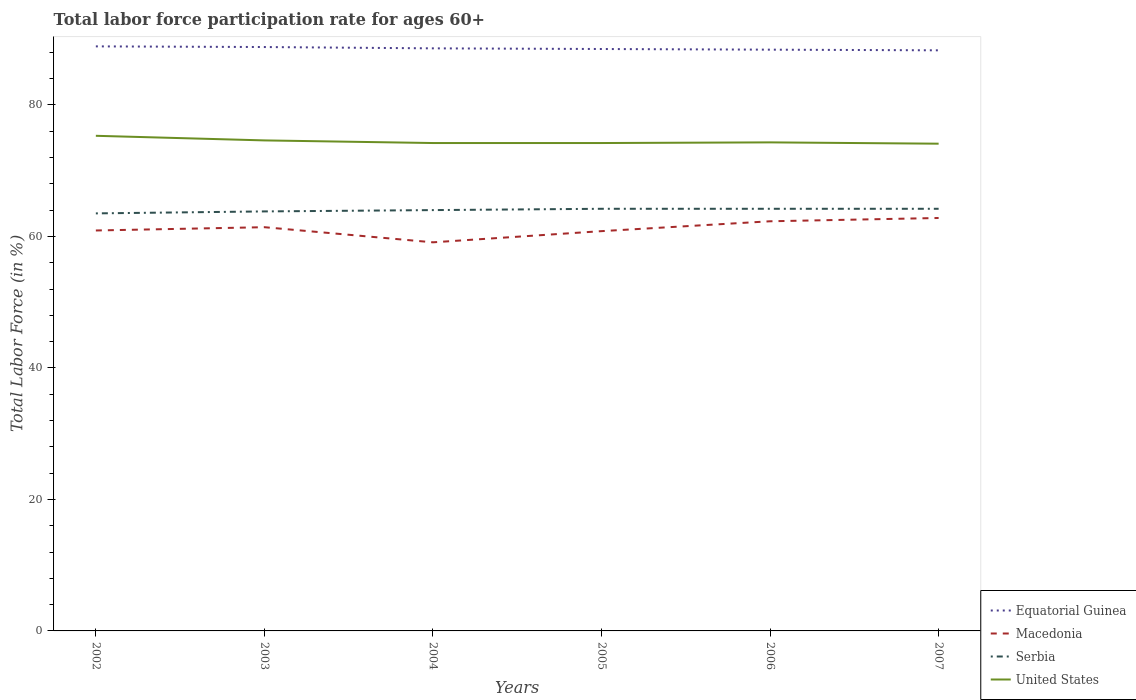How many different coloured lines are there?
Provide a short and direct response. 4. Does the line corresponding to Equatorial Guinea intersect with the line corresponding to Serbia?
Make the answer very short. No. Across all years, what is the maximum labor force participation rate in Serbia?
Your answer should be very brief. 63.5. In which year was the labor force participation rate in United States maximum?
Your answer should be compact. 2007. What is the total labor force participation rate in United States in the graph?
Offer a very short reply. -0.1. What is the difference between the highest and the second highest labor force participation rate in Macedonia?
Give a very brief answer. 3.7. How many lines are there?
Keep it short and to the point. 4. What is the difference between two consecutive major ticks on the Y-axis?
Give a very brief answer. 20. Does the graph contain any zero values?
Keep it short and to the point. No. Where does the legend appear in the graph?
Provide a succinct answer. Bottom right. How many legend labels are there?
Make the answer very short. 4. What is the title of the graph?
Provide a succinct answer. Total labor force participation rate for ages 60+. What is the Total Labor Force (in %) in Equatorial Guinea in 2002?
Your response must be concise. 88.9. What is the Total Labor Force (in %) of Macedonia in 2002?
Provide a succinct answer. 60.9. What is the Total Labor Force (in %) of Serbia in 2002?
Make the answer very short. 63.5. What is the Total Labor Force (in %) of United States in 2002?
Ensure brevity in your answer.  75.3. What is the Total Labor Force (in %) of Equatorial Guinea in 2003?
Make the answer very short. 88.8. What is the Total Labor Force (in %) in Macedonia in 2003?
Provide a short and direct response. 61.4. What is the Total Labor Force (in %) in Serbia in 2003?
Make the answer very short. 63.8. What is the Total Labor Force (in %) in United States in 2003?
Make the answer very short. 74.6. What is the Total Labor Force (in %) in Equatorial Guinea in 2004?
Ensure brevity in your answer.  88.6. What is the Total Labor Force (in %) of Macedonia in 2004?
Provide a short and direct response. 59.1. What is the Total Labor Force (in %) in United States in 2004?
Provide a short and direct response. 74.2. What is the Total Labor Force (in %) of Equatorial Guinea in 2005?
Make the answer very short. 88.5. What is the Total Labor Force (in %) of Macedonia in 2005?
Your answer should be very brief. 60.8. What is the Total Labor Force (in %) of Serbia in 2005?
Your response must be concise. 64.2. What is the Total Labor Force (in %) of United States in 2005?
Your response must be concise. 74.2. What is the Total Labor Force (in %) in Equatorial Guinea in 2006?
Offer a very short reply. 88.4. What is the Total Labor Force (in %) in Macedonia in 2006?
Your answer should be compact. 62.3. What is the Total Labor Force (in %) of Serbia in 2006?
Your answer should be very brief. 64.2. What is the Total Labor Force (in %) of United States in 2006?
Offer a very short reply. 74.3. What is the Total Labor Force (in %) of Equatorial Guinea in 2007?
Your response must be concise. 88.3. What is the Total Labor Force (in %) of Macedonia in 2007?
Give a very brief answer. 62.8. What is the Total Labor Force (in %) of Serbia in 2007?
Keep it short and to the point. 64.2. What is the Total Labor Force (in %) in United States in 2007?
Offer a very short reply. 74.1. Across all years, what is the maximum Total Labor Force (in %) of Equatorial Guinea?
Your answer should be compact. 88.9. Across all years, what is the maximum Total Labor Force (in %) in Macedonia?
Your response must be concise. 62.8. Across all years, what is the maximum Total Labor Force (in %) in Serbia?
Keep it short and to the point. 64.2. Across all years, what is the maximum Total Labor Force (in %) in United States?
Make the answer very short. 75.3. Across all years, what is the minimum Total Labor Force (in %) of Equatorial Guinea?
Make the answer very short. 88.3. Across all years, what is the minimum Total Labor Force (in %) of Macedonia?
Provide a succinct answer. 59.1. Across all years, what is the minimum Total Labor Force (in %) of Serbia?
Provide a short and direct response. 63.5. Across all years, what is the minimum Total Labor Force (in %) of United States?
Give a very brief answer. 74.1. What is the total Total Labor Force (in %) in Equatorial Guinea in the graph?
Your answer should be compact. 531.5. What is the total Total Labor Force (in %) of Macedonia in the graph?
Ensure brevity in your answer.  367.3. What is the total Total Labor Force (in %) of Serbia in the graph?
Give a very brief answer. 383.9. What is the total Total Labor Force (in %) in United States in the graph?
Your answer should be compact. 446.7. What is the difference between the Total Labor Force (in %) in Equatorial Guinea in 2002 and that in 2003?
Your answer should be very brief. 0.1. What is the difference between the Total Labor Force (in %) of Macedonia in 2002 and that in 2003?
Keep it short and to the point. -0.5. What is the difference between the Total Labor Force (in %) of Serbia in 2002 and that in 2003?
Make the answer very short. -0.3. What is the difference between the Total Labor Force (in %) of United States in 2002 and that in 2004?
Your response must be concise. 1.1. What is the difference between the Total Labor Force (in %) in Serbia in 2002 and that in 2005?
Your response must be concise. -0.7. What is the difference between the Total Labor Force (in %) in Equatorial Guinea in 2002 and that in 2006?
Your answer should be very brief. 0.5. What is the difference between the Total Labor Force (in %) of United States in 2002 and that in 2006?
Provide a short and direct response. 1. What is the difference between the Total Labor Force (in %) in Equatorial Guinea in 2002 and that in 2007?
Offer a terse response. 0.6. What is the difference between the Total Labor Force (in %) of Serbia in 2002 and that in 2007?
Your answer should be very brief. -0.7. What is the difference between the Total Labor Force (in %) of Equatorial Guinea in 2003 and that in 2004?
Provide a short and direct response. 0.2. What is the difference between the Total Labor Force (in %) of Macedonia in 2003 and that in 2004?
Your answer should be compact. 2.3. What is the difference between the Total Labor Force (in %) in United States in 2003 and that in 2004?
Your response must be concise. 0.4. What is the difference between the Total Labor Force (in %) in Macedonia in 2003 and that in 2005?
Make the answer very short. 0.6. What is the difference between the Total Labor Force (in %) of United States in 2003 and that in 2005?
Your answer should be compact. 0.4. What is the difference between the Total Labor Force (in %) of Equatorial Guinea in 2003 and that in 2006?
Make the answer very short. 0.4. What is the difference between the Total Labor Force (in %) of Macedonia in 2003 and that in 2006?
Provide a succinct answer. -0.9. What is the difference between the Total Labor Force (in %) in Macedonia in 2004 and that in 2005?
Provide a succinct answer. -1.7. What is the difference between the Total Labor Force (in %) in Macedonia in 2004 and that in 2007?
Ensure brevity in your answer.  -3.7. What is the difference between the Total Labor Force (in %) in United States in 2004 and that in 2007?
Your answer should be compact. 0.1. What is the difference between the Total Labor Force (in %) of United States in 2005 and that in 2006?
Provide a short and direct response. -0.1. What is the difference between the Total Labor Force (in %) of Serbia in 2005 and that in 2007?
Keep it short and to the point. 0. What is the difference between the Total Labor Force (in %) of United States in 2005 and that in 2007?
Make the answer very short. 0.1. What is the difference between the Total Labor Force (in %) of Serbia in 2006 and that in 2007?
Offer a terse response. 0. What is the difference between the Total Labor Force (in %) in Equatorial Guinea in 2002 and the Total Labor Force (in %) in Macedonia in 2003?
Your answer should be very brief. 27.5. What is the difference between the Total Labor Force (in %) in Equatorial Guinea in 2002 and the Total Labor Force (in %) in Serbia in 2003?
Your answer should be compact. 25.1. What is the difference between the Total Labor Force (in %) in Macedonia in 2002 and the Total Labor Force (in %) in United States in 2003?
Provide a succinct answer. -13.7. What is the difference between the Total Labor Force (in %) of Serbia in 2002 and the Total Labor Force (in %) of United States in 2003?
Keep it short and to the point. -11.1. What is the difference between the Total Labor Force (in %) in Equatorial Guinea in 2002 and the Total Labor Force (in %) in Macedonia in 2004?
Provide a short and direct response. 29.8. What is the difference between the Total Labor Force (in %) in Equatorial Guinea in 2002 and the Total Labor Force (in %) in Serbia in 2004?
Your answer should be very brief. 24.9. What is the difference between the Total Labor Force (in %) in Macedonia in 2002 and the Total Labor Force (in %) in Serbia in 2004?
Provide a succinct answer. -3.1. What is the difference between the Total Labor Force (in %) of Macedonia in 2002 and the Total Labor Force (in %) of United States in 2004?
Your response must be concise. -13.3. What is the difference between the Total Labor Force (in %) of Equatorial Guinea in 2002 and the Total Labor Force (in %) of Macedonia in 2005?
Provide a short and direct response. 28.1. What is the difference between the Total Labor Force (in %) in Equatorial Guinea in 2002 and the Total Labor Force (in %) in Serbia in 2005?
Your answer should be very brief. 24.7. What is the difference between the Total Labor Force (in %) in Equatorial Guinea in 2002 and the Total Labor Force (in %) in United States in 2005?
Provide a short and direct response. 14.7. What is the difference between the Total Labor Force (in %) of Macedonia in 2002 and the Total Labor Force (in %) of Serbia in 2005?
Ensure brevity in your answer.  -3.3. What is the difference between the Total Labor Force (in %) in Serbia in 2002 and the Total Labor Force (in %) in United States in 2005?
Offer a very short reply. -10.7. What is the difference between the Total Labor Force (in %) of Equatorial Guinea in 2002 and the Total Labor Force (in %) of Macedonia in 2006?
Offer a very short reply. 26.6. What is the difference between the Total Labor Force (in %) of Equatorial Guinea in 2002 and the Total Labor Force (in %) of Serbia in 2006?
Offer a terse response. 24.7. What is the difference between the Total Labor Force (in %) in Equatorial Guinea in 2002 and the Total Labor Force (in %) in United States in 2006?
Keep it short and to the point. 14.6. What is the difference between the Total Labor Force (in %) of Macedonia in 2002 and the Total Labor Force (in %) of Serbia in 2006?
Offer a terse response. -3.3. What is the difference between the Total Labor Force (in %) in Macedonia in 2002 and the Total Labor Force (in %) in United States in 2006?
Give a very brief answer. -13.4. What is the difference between the Total Labor Force (in %) of Serbia in 2002 and the Total Labor Force (in %) of United States in 2006?
Your answer should be compact. -10.8. What is the difference between the Total Labor Force (in %) of Equatorial Guinea in 2002 and the Total Labor Force (in %) of Macedonia in 2007?
Make the answer very short. 26.1. What is the difference between the Total Labor Force (in %) in Equatorial Guinea in 2002 and the Total Labor Force (in %) in Serbia in 2007?
Provide a short and direct response. 24.7. What is the difference between the Total Labor Force (in %) of Macedonia in 2002 and the Total Labor Force (in %) of Serbia in 2007?
Your response must be concise. -3.3. What is the difference between the Total Labor Force (in %) of Equatorial Guinea in 2003 and the Total Labor Force (in %) of Macedonia in 2004?
Keep it short and to the point. 29.7. What is the difference between the Total Labor Force (in %) of Equatorial Guinea in 2003 and the Total Labor Force (in %) of Serbia in 2004?
Offer a very short reply. 24.8. What is the difference between the Total Labor Force (in %) of Equatorial Guinea in 2003 and the Total Labor Force (in %) of United States in 2004?
Keep it short and to the point. 14.6. What is the difference between the Total Labor Force (in %) in Macedonia in 2003 and the Total Labor Force (in %) in Serbia in 2004?
Your answer should be compact. -2.6. What is the difference between the Total Labor Force (in %) in Equatorial Guinea in 2003 and the Total Labor Force (in %) in Macedonia in 2005?
Make the answer very short. 28. What is the difference between the Total Labor Force (in %) of Equatorial Guinea in 2003 and the Total Labor Force (in %) of Serbia in 2005?
Keep it short and to the point. 24.6. What is the difference between the Total Labor Force (in %) of Macedonia in 2003 and the Total Labor Force (in %) of Serbia in 2005?
Provide a succinct answer. -2.8. What is the difference between the Total Labor Force (in %) in Serbia in 2003 and the Total Labor Force (in %) in United States in 2005?
Make the answer very short. -10.4. What is the difference between the Total Labor Force (in %) in Equatorial Guinea in 2003 and the Total Labor Force (in %) in Macedonia in 2006?
Keep it short and to the point. 26.5. What is the difference between the Total Labor Force (in %) in Equatorial Guinea in 2003 and the Total Labor Force (in %) in Serbia in 2006?
Offer a terse response. 24.6. What is the difference between the Total Labor Force (in %) in Equatorial Guinea in 2003 and the Total Labor Force (in %) in Serbia in 2007?
Give a very brief answer. 24.6. What is the difference between the Total Labor Force (in %) of Serbia in 2003 and the Total Labor Force (in %) of United States in 2007?
Ensure brevity in your answer.  -10.3. What is the difference between the Total Labor Force (in %) of Equatorial Guinea in 2004 and the Total Labor Force (in %) of Macedonia in 2005?
Ensure brevity in your answer.  27.8. What is the difference between the Total Labor Force (in %) in Equatorial Guinea in 2004 and the Total Labor Force (in %) in Serbia in 2005?
Offer a terse response. 24.4. What is the difference between the Total Labor Force (in %) of Macedonia in 2004 and the Total Labor Force (in %) of United States in 2005?
Make the answer very short. -15.1. What is the difference between the Total Labor Force (in %) in Equatorial Guinea in 2004 and the Total Labor Force (in %) in Macedonia in 2006?
Your response must be concise. 26.3. What is the difference between the Total Labor Force (in %) of Equatorial Guinea in 2004 and the Total Labor Force (in %) of Serbia in 2006?
Offer a terse response. 24.4. What is the difference between the Total Labor Force (in %) in Macedonia in 2004 and the Total Labor Force (in %) in Serbia in 2006?
Provide a short and direct response. -5.1. What is the difference between the Total Labor Force (in %) in Macedonia in 2004 and the Total Labor Force (in %) in United States in 2006?
Offer a terse response. -15.2. What is the difference between the Total Labor Force (in %) of Equatorial Guinea in 2004 and the Total Labor Force (in %) of Macedonia in 2007?
Your response must be concise. 25.8. What is the difference between the Total Labor Force (in %) of Equatorial Guinea in 2004 and the Total Labor Force (in %) of Serbia in 2007?
Your response must be concise. 24.4. What is the difference between the Total Labor Force (in %) in Macedonia in 2004 and the Total Labor Force (in %) in Serbia in 2007?
Your response must be concise. -5.1. What is the difference between the Total Labor Force (in %) of Macedonia in 2004 and the Total Labor Force (in %) of United States in 2007?
Ensure brevity in your answer.  -15. What is the difference between the Total Labor Force (in %) in Serbia in 2004 and the Total Labor Force (in %) in United States in 2007?
Make the answer very short. -10.1. What is the difference between the Total Labor Force (in %) in Equatorial Guinea in 2005 and the Total Labor Force (in %) in Macedonia in 2006?
Your response must be concise. 26.2. What is the difference between the Total Labor Force (in %) of Equatorial Guinea in 2005 and the Total Labor Force (in %) of Serbia in 2006?
Offer a very short reply. 24.3. What is the difference between the Total Labor Force (in %) of Equatorial Guinea in 2005 and the Total Labor Force (in %) of United States in 2006?
Make the answer very short. 14.2. What is the difference between the Total Labor Force (in %) of Serbia in 2005 and the Total Labor Force (in %) of United States in 2006?
Provide a succinct answer. -10.1. What is the difference between the Total Labor Force (in %) in Equatorial Guinea in 2005 and the Total Labor Force (in %) in Macedonia in 2007?
Keep it short and to the point. 25.7. What is the difference between the Total Labor Force (in %) of Equatorial Guinea in 2005 and the Total Labor Force (in %) of Serbia in 2007?
Your answer should be compact. 24.3. What is the difference between the Total Labor Force (in %) in Macedonia in 2005 and the Total Labor Force (in %) in United States in 2007?
Provide a succinct answer. -13.3. What is the difference between the Total Labor Force (in %) of Equatorial Guinea in 2006 and the Total Labor Force (in %) of Macedonia in 2007?
Ensure brevity in your answer.  25.6. What is the difference between the Total Labor Force (in %) in Equatorial Guinea in 2006 and the Total Labor Force (in %) in Serbia in 2007?
Give a very brief answer. 24.2. What is the difference between the Total Labor Force (in %) in Equatorial Guinea in 2006 and the Total Labor Force (in %) in United States in 2007?
Your answer should be very brief. 14.3. What is the difference between the Total Labor Force (in %) of Macedonia in 2006 and the Total Labor Force (in %) of Serbia in 2007?
Keep it short and to the point. -1.9. What is the difference between the Total Labor Force (in %) in Serbia in 2006 and the Total Labor Force (in %) in United States in 2007?
Keep it short and to the point. -9.9. What is the average Total Labor Force (in %) in Equatorial Guinea per year?
Keep it short and to the point. 88.58. What is the average Total Labor Force (in %) of Macedonia per year?
Provide a succinct answer. 61.22. What is the average Total Labor Force (in %) in Serbia per year?
Your response must be concise. 63.98. What is the average Total Labor Force (in %) in United States per year?
Your response must be concise. 74.45. In the year 2002, what is the difference between the Total Labor Force (in %) of Equatorial Guinea and Total Labor Force (in %) of Macedonia?
Make the answer very short. 28. In the year 2002, what is the difference between the Total Labor Force (in %) in Equatorial Guinea and Total Labor Force (in %) in Serbia?
Offer a very short reply. 25.4. In the year 2002, what is the difference between the Total Labor Force (in %) of Equatorial Guinea and Total Labor Force (in %) of United States?
Your answer should be compact. 13.6. In the year 2002, what is the difference between the Total Labor Force (in %) of Macedonia and Total Labor Force (in %) of United States?
Provide a short and direct response. -14.4. In the year 2002, what is the difference between the Total Labor Force (in %) in Serbia and Total Labor Force (in %) in United States?
Provide a short and direct response. -11.8. In the year 2003, what is the difference between the Total Labor Force (in %) of Equatorial Guinea and Total Labor Force (in %) of Macedonia?
Your answer should be compact. 27.4. In the year 2003, what is the difference between the Total Labor Force (in %) of Macedonia and Total Labor Force (in %) of United States?
Keep it short and to the point. -13.2. In the year 2003, what is the difference between the Total Labor Force (in %) in Serbia and Total Labor Force (in %) in United States?
Your answer should be very brief. -10.8. In the year 2004, what is the difference between the Total Labor Force (in %) in Equatorial Guinea and Total Labor Force (in %) in Macedonia?
Make the answer very short. 29.5. In the year 2004, what is the difference between the Total Labor Force (in %) in Equatorial Guinea and Total Labor Force (in %) in Serbia?
Offer a very short reply. 24.6. In the year 2004, what is the difference between the Total Labor Force (in %) of Equatorial Guinea and Total Labor Force (in %) of United States?
Your answer should be compact. 14.4. In the year 2004, what is the difference between the Total Labor Force (in %) in Macedonia and Total Labor Force (in %) in United States?
Keep it short and to the point. -15.1. In the year 2004, what is the difference between the Total Labor Force (in %) of Serbia and Total Labor Force (in %) of United States?
Keep it short and to the point. -10.2. In the year 2005, what is the difference between the Total Labor Force (in %) of Equatorial Guinea and Total Labor Force (in %) of Macedonia?
Give a very brief answer. 27.7. In the year 2005, what is the difference between the Total Labor Force (in %) of Equatorial Guinea and Total Labor Force (in %) of Serbia?
Provide a short and direct response. 24.3. In the year 2005, what is the difference between the Total Labor Force (in %) of Equatorial Guinea and Total Labor Force (in %) of United States?
Provide a short and direct response. 14.3. In the year 2005, what is the difference between the Total Labor Force (in %) in Serbia and Total Labor Force (in %) in United States?
Your answer should be very brief. -10. In the year 2006, what is the difference between the Total Labor Force (in %) in Equatorial Guinea and Total Labor Force (in %) in Macedonia?
Offer a terse response. 26.1. In the year 2006, what is the difference between the Total Labor Force (in %) of Equatorial Guinea and Total Labor Force (in %) of Serbia?
Your answer should be compact. 24.2. In the year 2006, what is the difference between the Total Labor Force (in %) in Macedonia and Total Labor Force (in %) in Serbia?
Give a very brief answer. -1.9. In the year 2006, what is the difference between the Total Labor Force (in %) of Macedonia and Total Labor Force (in %) of United States?
Your response must be concise. -12. In the year 2006, what is the difference between the Total Labor Force (in %) of Serbia and Total Labor Force (in %) of United States?
Offer a terse response. -10.1. In the year 2007, what is the difference between the Total Labor Force (in %) of Equatorial Guinea and Total Labor Force (in %) of Macedonia?
Provide a succinct answer. 25.5. In the year 2007, what is the difference between the Total Labor Force (in %) in Equatorial Guinea and Total Labor Force (in %) in Serbia?
Provide a succinct answer. 24.1. In the year 2007, what is the difference between the Total Labor Force (in %) in Equatorial Guinea and Total Labor Force (in %) in United States?
Your response must be concise. 14.2. In the year 2007, what is the difference between the Total Labor Force (in %) in Macedonia and Total Labor Force (in %) in United States?
Your answer should be very brief. -11.3. In the year 2007, what is the difference between the Total Labor Force (in %) of Serbia and Total Labor Force (in %) of United States?
Your answer should be very brief. -9.9. What is the ratio of the Total Labor Force (in %) of Equatorial Guinea in 2002 to that in 2003?
Make the answer very short. 1. What is the ratio of the Total Labor Force (in %) of Serbia in 2002 to that in 2003?
Your answer should be compact. 1. What is the ratio of the Total Labor Force (in %) in United States in 2002 to that in 2003?
Your answer should be compact. 1.01. What is the ratio of the Total Labor Force (in %) of Macedonia in 2002 to that in 2004?
Ensure brevity in your answer.  1.03. What is the ratio of the Total Labor Force (in %) in United States in 2002 to that in 2004?
Offer a very short reply. 1.01. What is the ratio of the Total Labor Force (in %) of Equatorial Guinea in 2002 to that in 2005?
Keep it short and to the point. 1. What is the ratio of the Total Labor Force (in %) of Macedonia in 2002 to that in 2005?
Provide a succinct answer. 1. What is the ratio of the Total Labor Force (in %) in United States in 2002 to that in 2005?
Keep it short and to the point. 1.01. What is the ratio of the Total Labor Force (in %) of Macedonia in 2002 to that in 2006?
Your answer should be compact. 0.98. What is the ratio of the Total Labor Force (in %) in United States in 2002 to that in 2006?
Your answer should be very brief. 1.01. What is the ratio of the Total Labor Force (in %) of Equatorial Guinea in 2002 to that in 2007?
Ensure brevity in your answer.  1.01. What is the ratio of the Total Labor Force (in %) of Macedonia in 2002 to that in 2007?
Provide a succinct answer. 0.97. What is the ratio of the Total Labor Force (in %) of Serbia in 2002 to that in 2007?
Give a very brief answer. 0.99. What is the ratio of the Total Labor Force (in %) in United States in 2002 to that in 2007?
Your response must be concise. 1.02. What is the ratio of the Total Labor Force (in %) in Macedonia in 2003 to that in 2004?
Ensure brevity in your answer.  1.04. What is the ratio of the Total Labor Force (in %) in United States in 2003 to that in 2004?
Your answer should be very brief. 1.01. What is the ratio of the Total Labor Force (in %) of Macedonia in 2003 to that in 2005?
Your response must be concise. 1.01. What is the ratio of the Total Labor Force (in %) in Serbia in 2003 to that in 2005?
Your response must be concise. 0.99. What is the ratio of the Total Labor Force (in %) of United States in 2003 to that in 2005?
Give a very brief answer. 1.01. What is the ratio of the Total Labor Force (in %) in Macedonia in 2003 to that in 2006?
Offer a very short reply. 0.99. What is the ratio of the Total Labor Force (in %) of United States in 2003 to that in 2006?
Make the answer very short. 1. What is the ratio of the Total Labor Force (in %) of Macedonia in 2003 to that in 2007?
Provide a short and direct response. 0.98. What is the ratio of the Total Labor Force (in %) of Serbia in 2003 to that in 2007?
Provide a succinct answer. 0.99. What is the ratio of the Total Labor Force (in %) of United States in 2003 to that in 2007?
Your answer should be very brief. 1.01. What is the ratio of the Total Labor Force (in %) in Macedonia in 2004 to that in 2005?
Your response must be concise. 0.97. What is the ratio of the Total Labor Force (in %) in Serbia in 2004 to that in 2005?
Your response must be concise. 1. What is the ratio of the Total Labor Force (in %) of Macedonia in 2004 to that in 2006?
Provide a short and direct response. 0.95. What is the ratio of the Total Labor Force (in %) of Serbia in 2004 to that in 2006?
Your answer should be very brief. 1. What is the ratio of the Total Labor Force (in %) of Equatorial Guinea in 2004 to that in 2007?
Offer a terse response. 1. What is the ratio of the Total Labor Force (in %) of Macedonia in 2004 to that in 2007?
Ensure brevity in your answer.  0.94. What is the ratio of the Total Labor Force (in %) of Serbia in 2004 to that in 2007?
Your answer should be very brief. 1. What is the ratio of the Total Labor Force (in %) of United States in 2004 to that in 2007?
Your response must be concise. 1. What is the ratio of the Total Labor Force (in %) of Macedonia in 2005 to that in 2006?
Provide a short and direct response. 0.98. What is the ratio of the Total Labor Force (in %) of United States in 2005 to that in 2006?
Make the answer very short. 1. What is the ratio of the Total Labor Force (in %) of Equatorial Guinea in 2005 to that in 2007?
Provide a short and direct response. 1. What is the ratio of the Total Labor Force (in %) in Macedonia in 2005 to that in 2007?
Ensure brevity in your answer.  0.97. What is the ratio of the Total Labor Force (in %) in Serbia in 2005 to that in 2007?
Offer a terse response. 1. What is the ratio of the Total Labor Force (in %) in United States in 2005 to that in 2007?
Make the answer very short. 1. What is the ratio of the Total Labor Force (in %) in Macedonia in 2006 to that in 2007?
Your response must be concise. 0.99. What is the difference between the highest and the second highest Total Labor Force (in %) of Equatorial Guinea?
Offer a terse response. 0.1. What is the difference between the highest and the second highest Total Labor Force (in %) of United States?
Provide a short and direct response. 0.7. What is the difference between the highest and the lowest Total Labor Force (in %) of Equatorial Guinea?
Your response must be concise. 0.6. What is the difference between the highest and the lowest Total Labor Force (in %) in Macedonia?
Your answer should be very brief. 3.7. What is the difference between the highest and the lowest Total Labor Force (in %) of Serbia?
Your response must be concise. 0.7. 